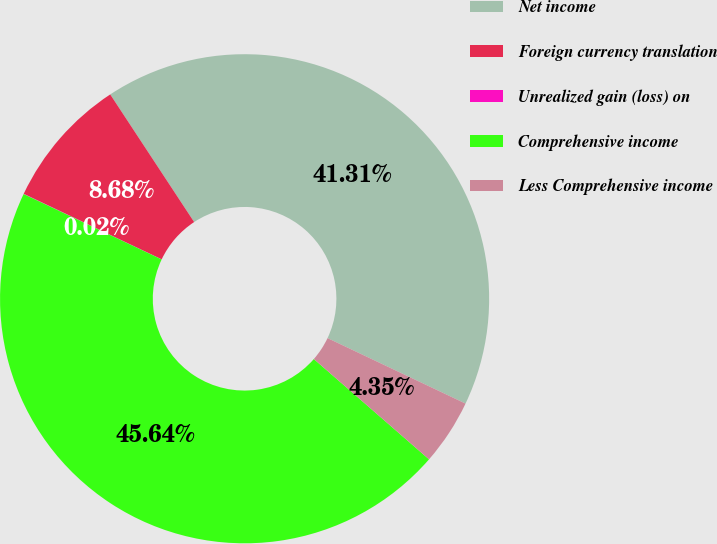<chart> <loc_0><loc_0><loc_500><loc_500><pie_chart><fcel>Net income<fcel>Foreign currency translation<fcel>Unrealized gain (loss) on<fcel>Comprehensive income<fcel>Less Comprehensive income<nl><fcel>41.31%<fcel>8.68%<fcel>0.02%<fcel>45.64%<fcel>4.35%<nl></chart> 